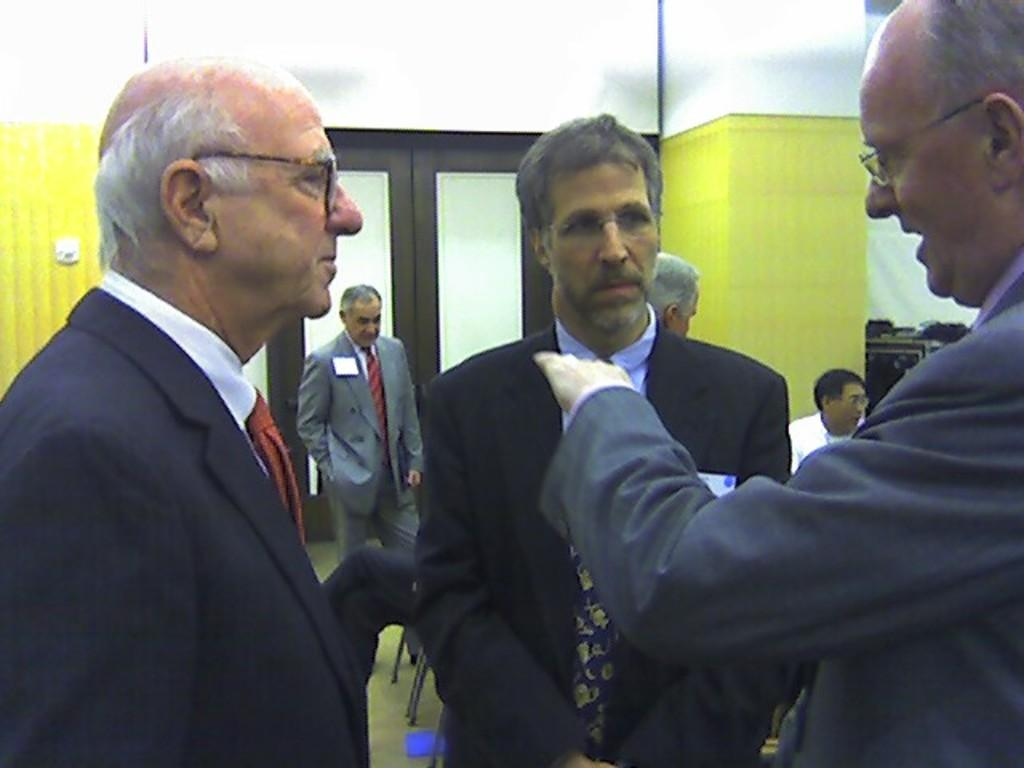What can be seen in the foreground of the image? There are people in the foreground of the image. What else can be seen in the image? There are people in the background of the image, as well as doors and some objects. Can you describe the doors in the background? Unfortunately, the facts provided do not give enough detail about the doors to describe them. What might the objects in the background be used for? The facts provided do not specify the purpose or function of the objects in the background. What is the average income of the people in the image? There is no information about the income of the people in the image, so it cannot be determined. 